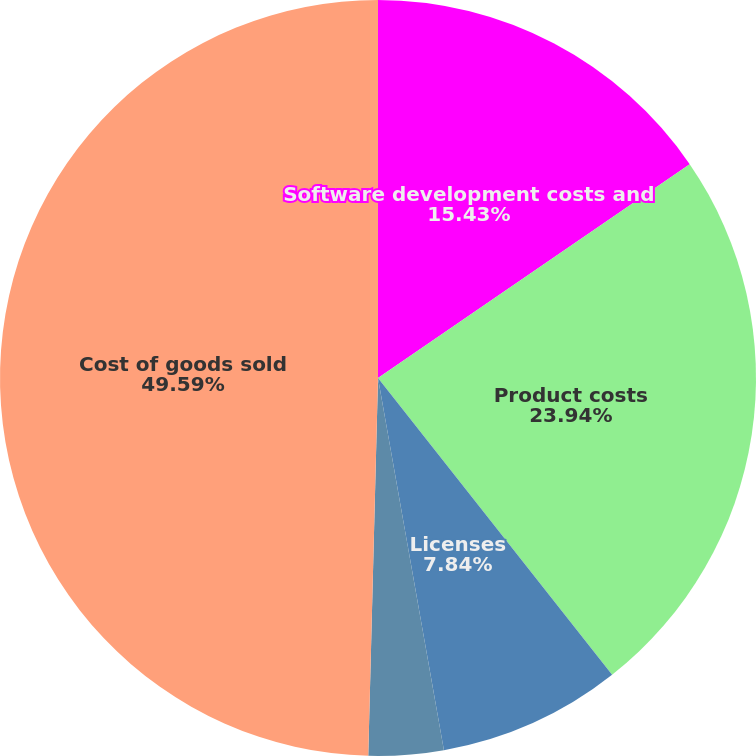<chart> <loc_0><loc_0><loc_500><loc_500><pie_chart><fcel>Software development costs and<fcel>Product costs<fcel>Licenses<fcel>Internal royalties<fcel>Cost of goods sold<nl><fcel>15.43%<fcel>23.94%<fcel>7.84%<fcel>3.2%<fcel>49.59%<nl></chart> 